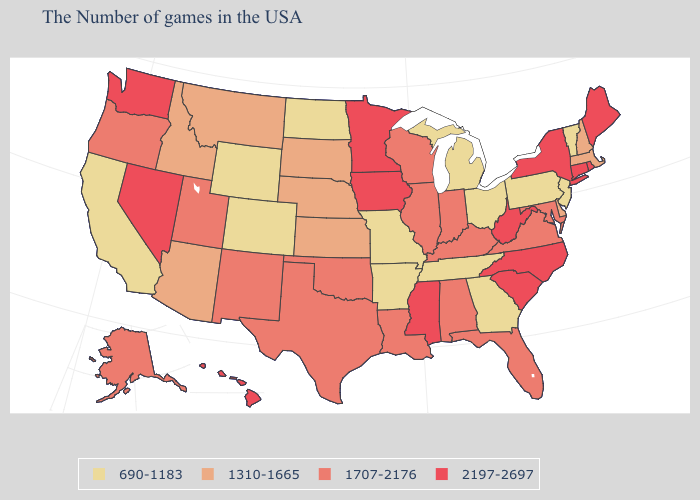Does the first symbol in the legend represent the smallest category?
Give a very brief answer. Yes. Which states hav the highest value in the Northeast?
Concise answer only. Maine, Rhode Island, Connecticut, New York. Among the states that border Maryland , which have the highest value?
Concise answer only. West Virginia. What is the value of Louisiana?
Write a very short answer. 1707-2176. Which states have the lowest value in the USA?
Write a very short answer. Vermont, New Jersey, Pennsylvania, Ohio, Georgia, Michigan, Tennessee, Missouri, Arkansas, North Dakota, Wyoming, Colorado, California. Which states hav the highest value in the West?
Write a very short answer. Nevada, Washington, Hawaii. Name the states that have a value in the range 2197-2697?
Answer briefly. Maine, Rhode Island, Connecticut, New York, North Carolina, South Carolina, West Virginia, Mississippi, Minnesota, Iowa, Nevada, Washington, Hawaii. Name the states that have a value in the range 1707-2176?
Answer briefly. Maryland, Virginia, Florida, Kentucky, Indiana, Alabama, Wisconsin, Illinois, Louisiana, Oklahoma, Texas, New Mexico, Utah, Oregon, Alaska. Does Washington have the lowest value in the West?
Be succinct. No. Among the states that border North Dakota , does Minnesota have the lowest value?
Be succinct. No. What is the value of Wyoming?
Answer briefly. 690-1183. Is the legend a continuous bar?
Keep it brief. No. Which states hav the highest value in the MidWest?
Be succinct. Minnesota, Iowa. Which states have the lowest value in the West?
Give a very brief answer. Wyoming, Colorado, California. 